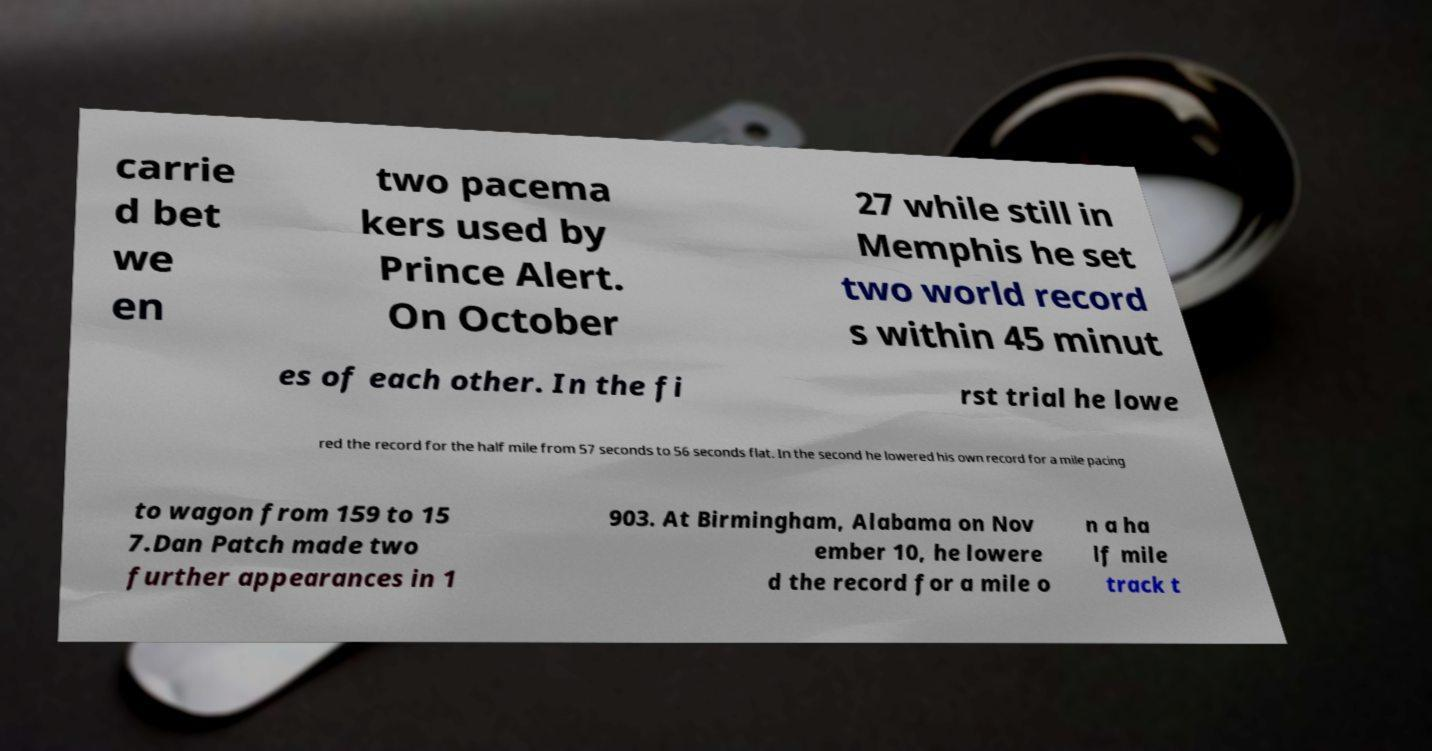Please identify and transcribe the text found in this image. carrie d bet we en two pacema kers used by Prince Alert. On October 27 while still in Memphis he set two world record s within 45 minut es of each other. In the fi rst trial he lowe red the record for the half mile from 57 seconds to 56 seconds flat. In the second he lowered his own record for a mile pacing to wagon from 159 to 15 7.Dan Patch made two further appearances in 1 903. At Birmingham, Alabama on Nov ember 10, he lowere d the record for a mile o n a ha lf mile track t 